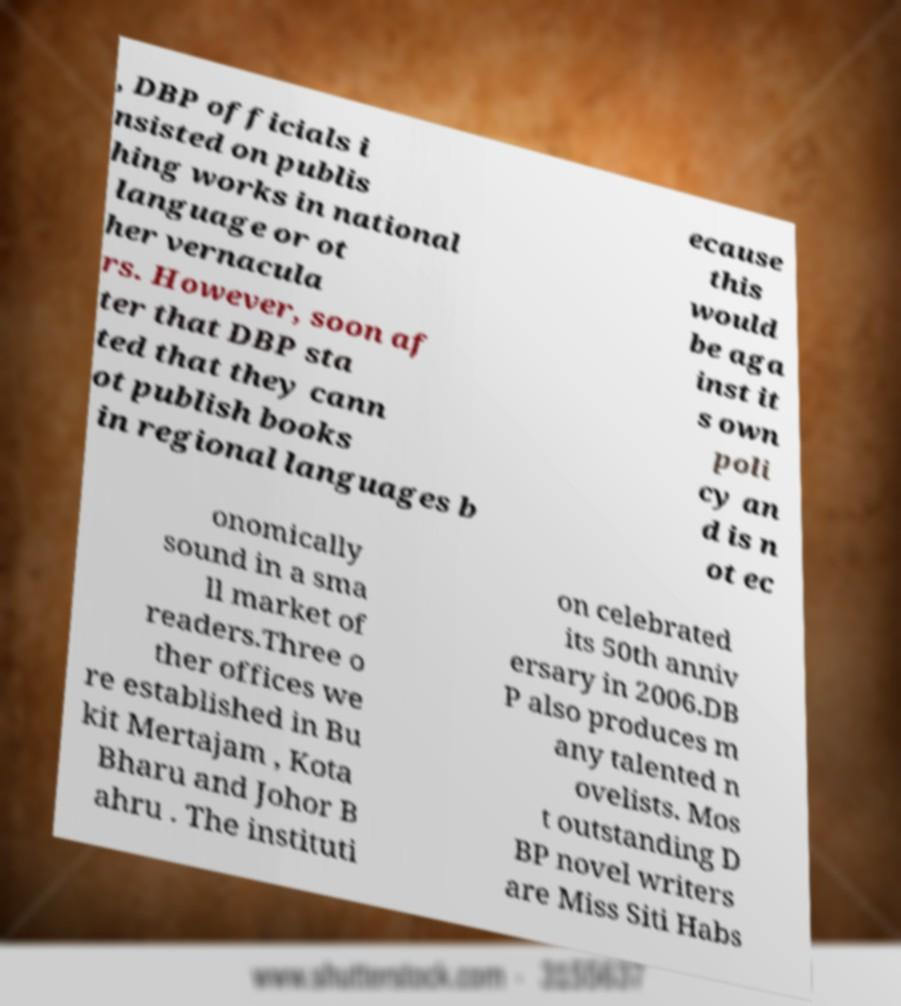Could you extract and type out the text from this image? , DBP officials i nsisted on publis hing works in national language or ot her vernacula rs. However, soon af ter that DBP sta ted that they cann ot publish books in regional languages b ecause this would be aga inst it s own poli cy an d is n ot ec onomically sound in a sma ll market of readers.Three o ther offices we re established in Bu kit Mertajam , Kota Bharu and Johor B ahru . The instituti on celebrated its 50th anniv ersary in 2006.DB P also produces m any talented n ovelists. Mos t outstanding D BP novel writers are Miss Siti Habs 